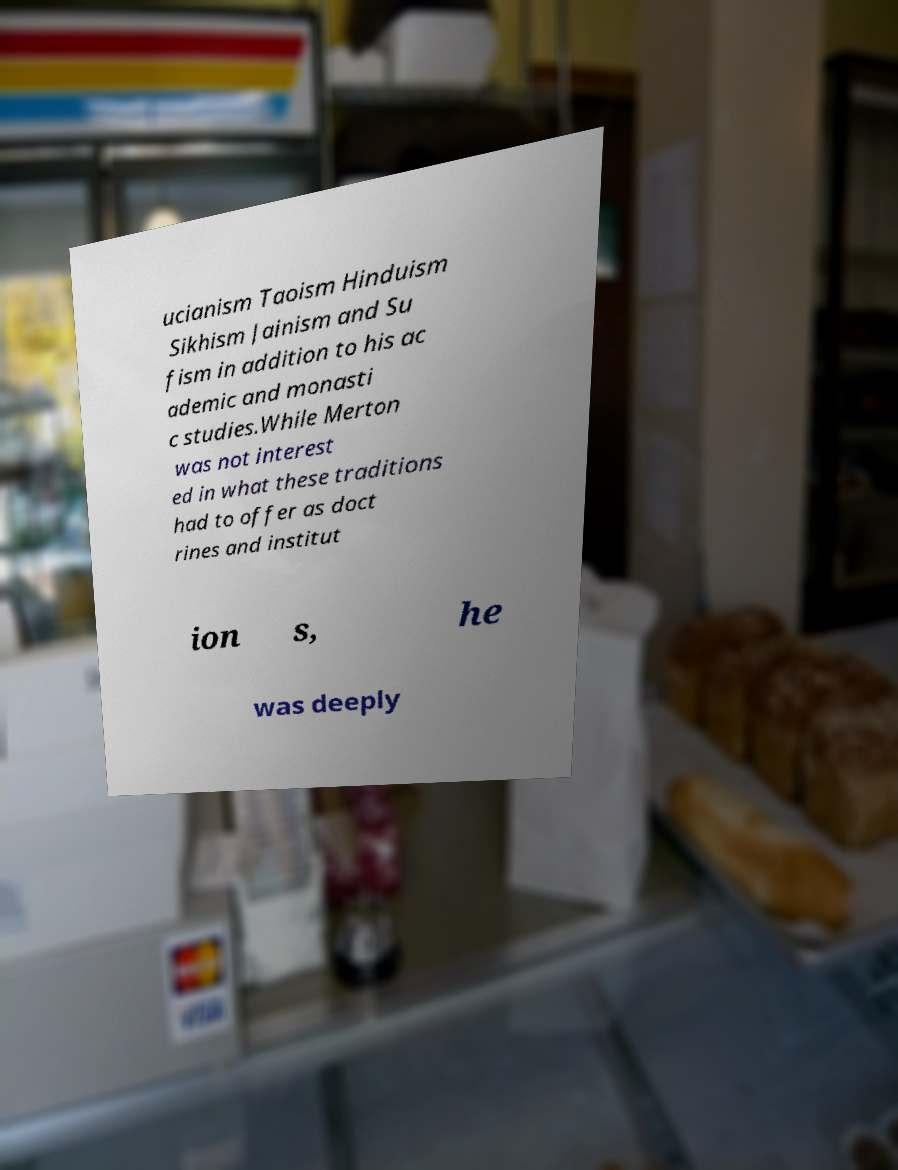For documentation purposes, I need the text within this image transcribed. Could you provide that? ucianism Taoism Hinduism Sikhism Jainism and Su fism in addition to his ac ademic and monasti c studies.While Merton was not interest ed in what these traditions had to offer as doct rines and institut ion s, he was deeply 